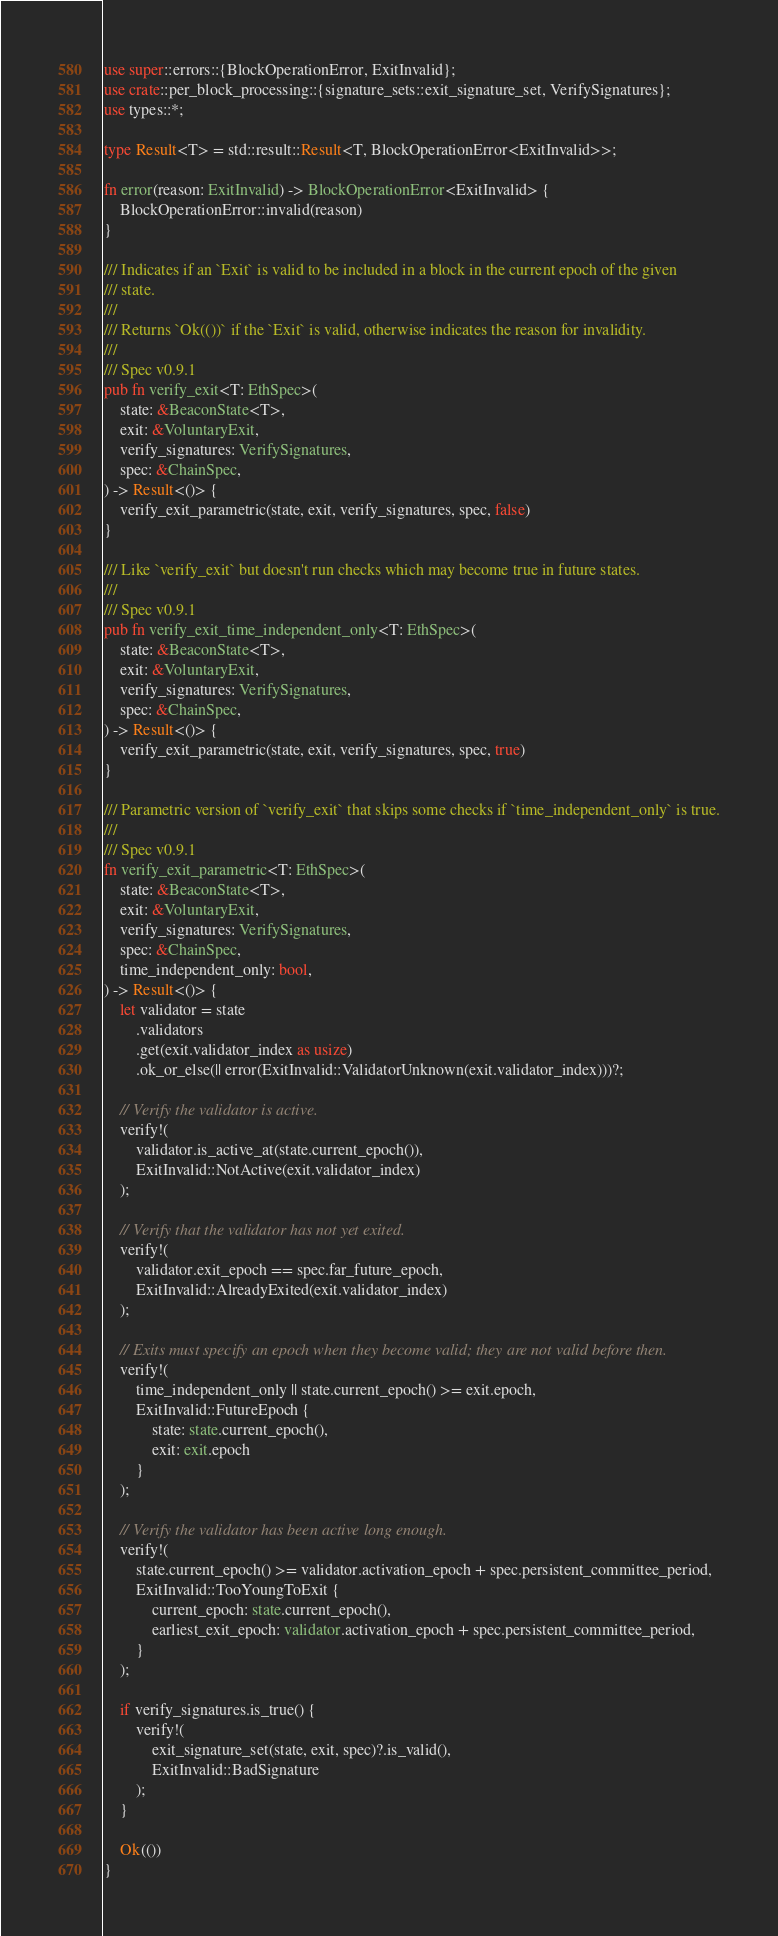<code> <loc_0><loc_0><loc_500><loc_500><_Rust_>use super::errors::{BlockOperationError, ExitInvalid};
use crate::per_block_processing::{signature_sets::exit_signature_set, VerifySignatures};
use types::*;

type Result<T> = std::result::Result<T, BlockOperationError<ExitInvalid>>;

fn error(reason: ExitInvalid) -> BlockOperationError<ExitInvalid> {
    BlockOperationError::invalid(reason)
}

/// Indicates if an `Exit` is valid to be included in a block in the current epoch of the given
/// state.
///
/// Returns `Ok(())` if the `Exit` is valid, otherwise indicates the reason for invalidity.
///
/// Spec v0.9.1
pub fn verify_exit<T: EthSpec>(
    state: &BeaconState<T>,
    exit: &VoluntaryExit,
    verify_signatures: VerifySignatures,
    spec: &ChainSpec,
) -> Result<()> {
    verify_exit_parametric(state, exit, verify_signatures, spec, false)
}

/// Like `verify_exit` but doesn't run checks which may become true in future states.
///
/// Spec v0.9.1
pub fn verify_exit_time_independent_only<T: EthSpec>(
    state: &BeaconState<T>,
    exit: &VoluntaryExit,
    verify_signatures: VerifySignatures,
    spec: &ChainSpec,
) -> Result<()> {
    verify_exit_parametric(state, exit, verify_signatures, spec, true)
}

/// Parametric version of `verify_exit` that skips some checks if `time_independent_only` is true.
///
/// Spec v0.9.1
fn verify_exit_parametric<T: EthSpec>(
    state: &BeaconState<T>,
    exit: &VoluntaryExit,
    verify_signatures: VerifySignatures,
    spec: &ChainSpec,
    time_independent_only: bool,
) -> Result<()> {
    let validator = state
        .validators
        .get(exit.validator_index as usize)
        .ok_or_else(|| error(ExitInvalid::ValidatorUnknown(exit.validator_index)))?;

    // Verify the validator is active.
    verify!(
        validator.is_active_at(state.current_epoch()),
        ExitInvalid::NotActive(exit.validator_index)
    );

    // Verify that the validator has not yet exited.
    verify!(
        validator.exit_epoch == spec.far_future_epoch,
        ExitInvalid::AlreadyExited(exit.validator_index)
    );

    // Exits must specify an epoch when they become valid; they are not valid before then.
    verify!(
        time_independent_only || state.current_epoch() >= exit.epoch,
        ExitInvalid::FutureEpoch {
            state: state.current_epoch(),
            exit: exit.epoch
        }
    );

    // Verify the validator has been active long enough.
    verify!(
        state.current_epoch() >= validator.activation_epoch + spec.persistent_committee_period,
        ExitInvalid::TooYoungToExit {
            current_epoch: state.current_epoch(),
            earliest_exit_epoch: validator.activation_epoch + spec.persistent_committee_period,
        }
    );

    if verify_signatures.is_true() {
        verify!(
            exit_signature_set(state, exit, spec)?.is_valid(),
            ExitInvalid::BadSignature
        );
    }

    Ok(())
}
</code> 